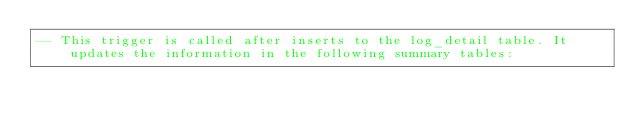Convert code to text. <code><loc_0><loc_0><loc_500><loc_500><_SQL_>-- This trigger is called after inserts to the log_detail table. It updates the information in the following summary tables:</code> 